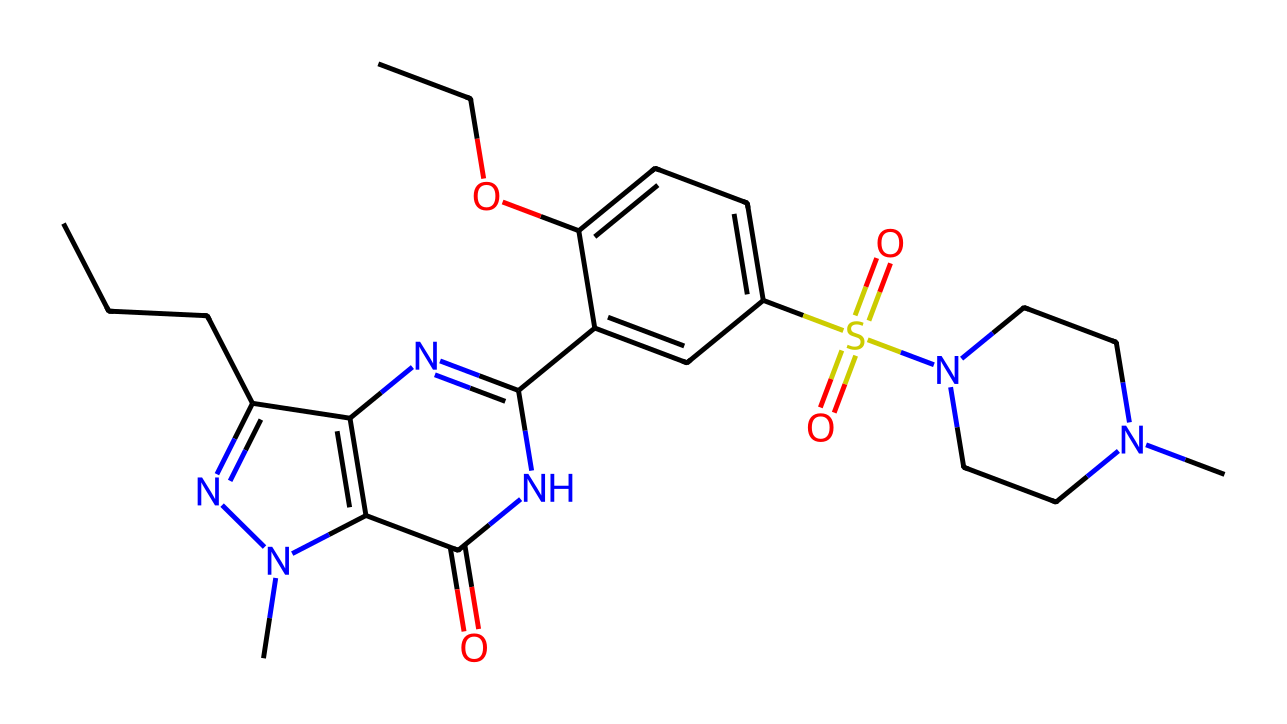What is the molecular formula of sildenafil? To determine the molecular formula, count the number of each type of atom represented in the SMILES notation. The structure includes carbon (C), hydrogen (H), nitrogen (N), oxygen (O), and sulfur (S). After analyzing, the molecular formula is found to be C22H30N6O4S.
Answer: C22H30N6O4S How many nitrogen atoms are present in the molecular structure? Counting the nitrogen atoms in the chemical structure from the SMILES notation, we find there are four nitrogen atoms. Each "N" represents one nitrogen in the molecular structure.
Answer: four What type of chemical bond connects the carbon and the nitrogen in the structure? The bond connecting carbon and nitrogen is primarily a single covalent bond based on the SMILES representation. Covalent bonds occur between nonmetals, such as carbon and nitrogen.
Answer: single covalent What functional groups are present in sildenafil? By analyzing the SMILES representation, we can identify the presence of a sulfonamide group (S(=O)(=O)N) and an alcohol group (-OH). These are characteristic functional groups that determine the chemical properties of sildenafil.
Answer: sulfonamide and alcohol How many rings are present in the molecular structure of sildenafil? Upon examining the structure from the SMILES notation, there are two aromatic rings present, which contribute to the drug's biological activity. Counting the distinct ring structures confirms this.
Answer: two Which part of the sildenafil molecule is primarily responsible for its pharmacological activity? The heterocyclic ring system, particularly the guanine-like structure that allows for specific enzyme binding, is primarily responsible for the pharmacological activity of sildenafil, as it interacts with phosphodiesterase type 5.
Answer: heterocyclic ring system What is the role of the sulfur atom in the sildenafil structure? The sulfur atom is part of the sulfonamide functional group, which plays a crucial role in the chemical reactivity and interaction of sildenafil with biological targets, further enhancing its efficacy as a pharmaceutical drug.
Answer: sulfonamide group 